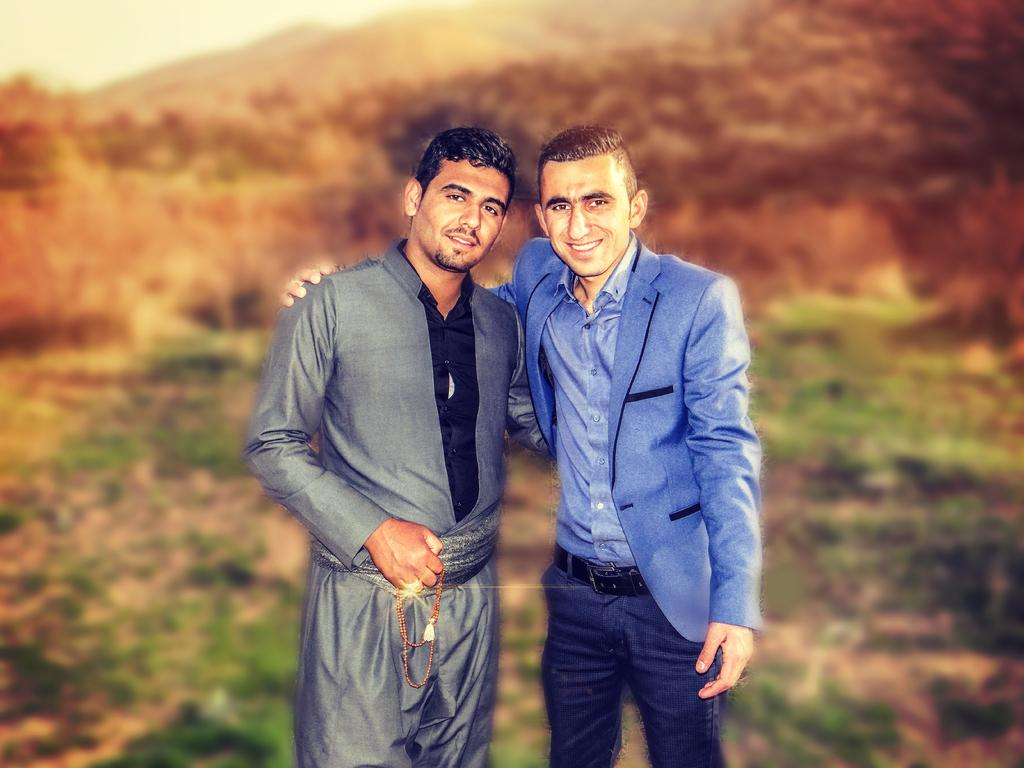How many people are present in the image? There are two people in the image. What can be seen in the background of the image? There are mountains and the sky visible in the background of the image. What type of terrain is present at the bottom of the image? There is grass on the surface at the bottom of the image. Are the two people in the image sisters? There is no information provided about the relationship between the two people in the image, so we cannot determine if they are sisters. 